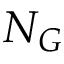Convert formula to latex. <formula><loc_0><loc_0><loc_500><loc_500>N _ { G }</formula> 